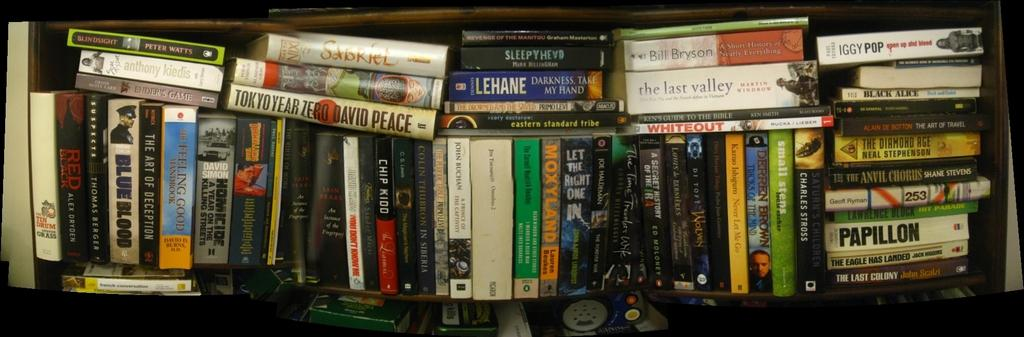<image>
Present a compact description of the photo's key features. several books on a shelf include one titled Papillon 